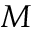<formula> <loc_0><loc_0><loc_500><loc_500>M</formula> 